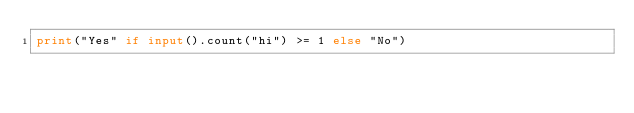Convert code to text. <code><loc_0><loc_0><loc_500><loc_500><_Python_>print("Yes" if input().count("hi") >= 1 else "No")
</code> 